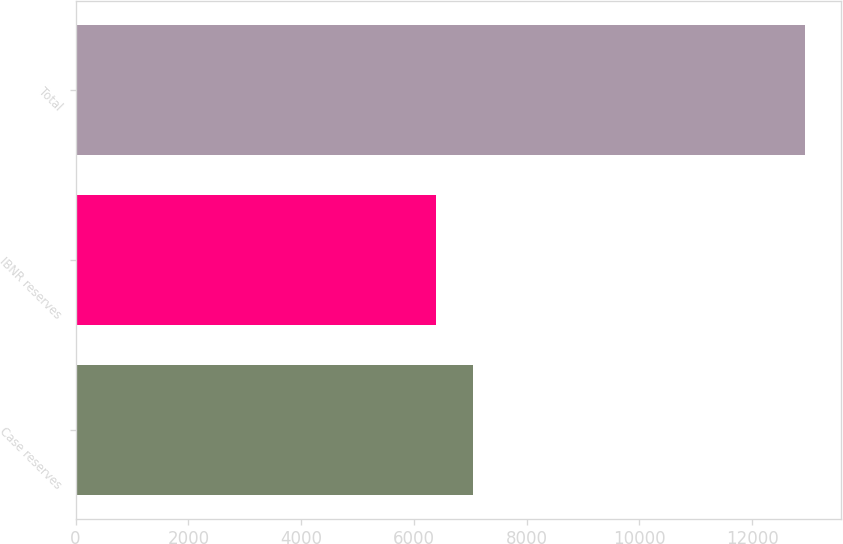Convert chart to OTSL. <chart><loc_0><loc_0><loc_500><loc_500><bar_chart><fcel>Case reserves<fcel>IBNR reserves<fcel>Total<nl><fcel>7049.9<fcel>6396<fcel>12935<nl></chart> 